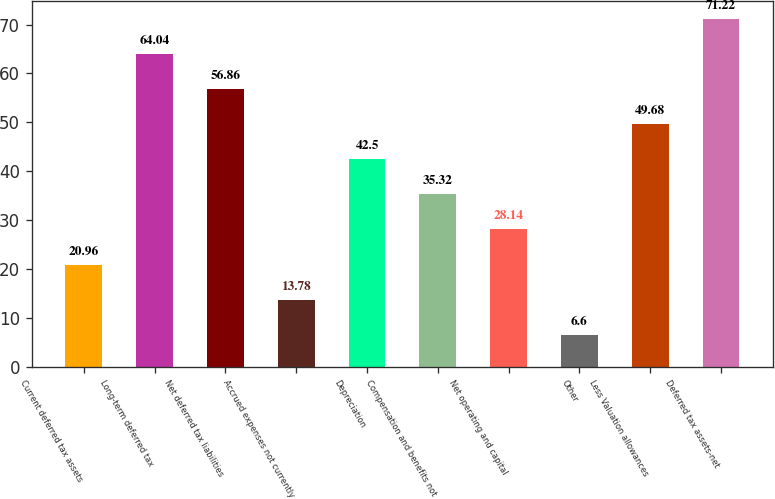Convert chart. <chart><loc_0><loc_0><loc_500><loc_500><bar_chart><fcel>Current deferred tax assets<fcel>Long-term deferred tax<fcel>Net deferred tax liabilities<fcel>Accrued expenses not currently<fcel>Depreciation<fcel>Compensation and benefits not<fcel>Net operating and capital<fcel>Other<fcel>Less Valuation allowances<fcel>Deferred tax assets-net<nl><fcel>20.96<fcel>64.04<fcel>56.86<fcel>13.78<fcel>42.5<fcel>35.32<fcel>28.14<fcel>6.6<fcel>49.68<fcel>71.22<nl></chart> 